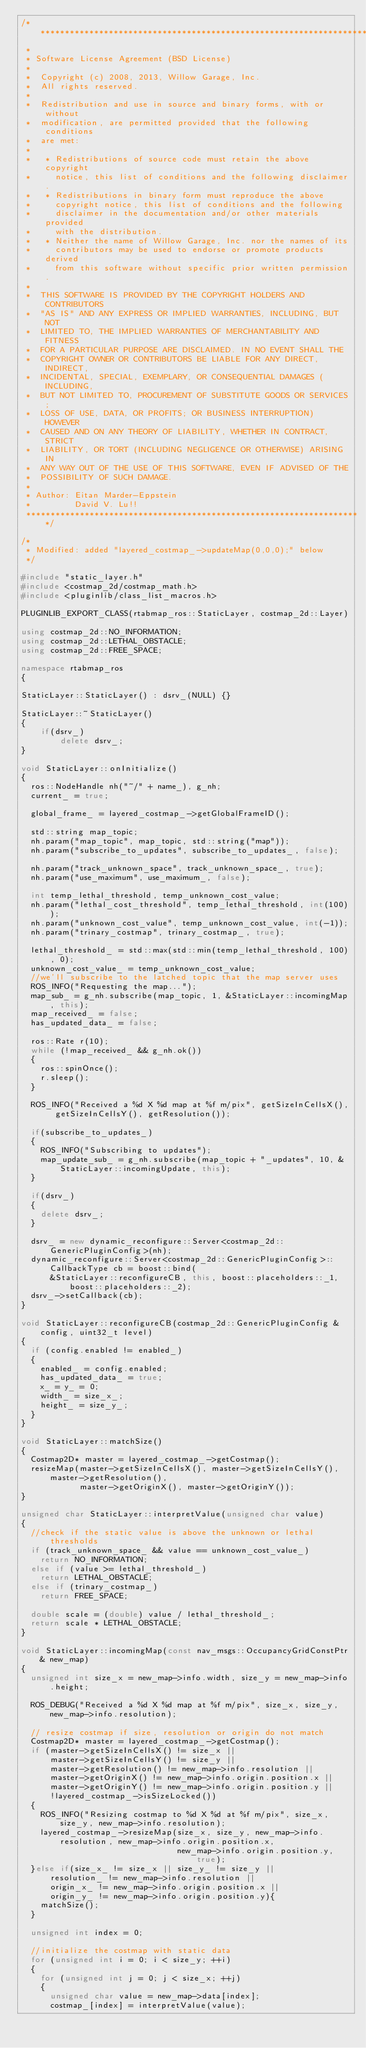<code> <loc_0><loc_0><loc_500><loc_500><_C++_>/*********************************************************************
 *
 * Software License Agreement (BSD License)
 *
 *  Copyright (c) 2008, 2013, Willow Garage, Inc.
 *  All rights reserved.
 *
 *  Redistribution and use in source and binary forms, with or without
 *  modification, are permitted provided that the following conditions
 *  are met:
 *
 *   * Redistributions of source code must retain the above copyright
 *     notice, this list of conditions and the following disclaimer.
 *   * Redistributions in binary form must reproduce the above
 *     copyright notice, this list of conditions and the following
 *     disclaimer in the documentation and/or other materials provided
 *     with the distribution.
 *   * Neither the name of Willow Garage, Inc. nor the names of its
 *     contributors may be used to endorse or promote products derived
 *     from this software without specific prior written permission.
 *
 *  THIS SOFTWARE IS PROVIDED BY THE COPYRIGHT HOLDERS AND CONTRIBUTORS
 *  "AS IS" AND ANY EXPRESS OR IMPLIED WARRANTIES, INCLUDING, BUT NOT
 *  LIMITED TO, THE IMPLIED WARRANTIES OF MERCHANTABILITY AND FITNESS
 *  FOR A PARTICULAR PURPOSE ARE DISCLAIMED. IN NO EVENT SHALL THE
 *  COPYRIGHT OWNER OR CONTRIBUTORS BE LIABLE FOR ANY DIRECT, INDIRECT,
 *  INCIDENTAL, SPECIAL, EXEMPLARY, OR CONSEQUENTIAL DAMAGES (INCLUDING,
 *  BUT NOT LIMITED TO, PROCUREMENT OF SUBSTITUTE GOODS OR SERVICES;
 *  LOSS OF USE, DATA, OR PROFITS; OR BUSINESS INTERRUPTION) HOWEVER
 *  CAUSED AND ON ANY THEORY OF LIABILITY, WHETHER IN CONTRACT, STRICT
 *  LIABILITY, OR TORT (INCLUDING NEGLIGENCE OR OTHERWISE) ARISING IN
 *  ANY WAY OUT OF THE USE OF THIS SOFTWARE, EVEN IF ADVISED OF THE
 *  POSSIBILITY OF SUCH DAMAGE.
 *
 * Author: Eitan Marder-Eppstein
 *         David V. Lu!!
 *********************************************************************/

/*
 * Modified: added "layered_costmap_->updateMap(0,0,0);" below
 */

#include "static_layer.h"
#include <costmap_2d/costmap_math.h>
#include <pluginlib/class_list_macros.h>

PLUGINLIB_EXPORT_CLASS(rtabmap_ros::StaticLayer, costmap_2d::Layer)

using costmap_2d::NO_INFORMATION;
using costmap_2d::LETHAL_OBSTACLE;
using costmap_2d::FREE_SPACE;

namespace rtabmap_ros
{

StaticLayer::StaticLayer() : dsrv_(NULL) {}

StaticLayer::~StaticLayer()
{
    if(dsrv_)
        delete dsrv_;
}

void StaticLayer::onInitialize()
{
  ros::NodeHandle nh("~/" + name_), g_nh;
  current_ = true;

  global_frame_ = layered_costmap_->getGlobalFrameID();

  std::string map_topic;
  nh.param("map_topic", map_topic, std::string("map"));
  nh.param("subscribe_to_updates", subscribe_to_updates_, false);
  
  nh.param("track_unknown_space", track_unknown_space_, true);
  nh.param("use_maximum", use_maximum_, false);

  int temp_lethal_threshold, temp_unknown_cost_value;
  nh.param("lethal_cost_threshold", temp_lethal_threshold, int(100));
  nh.param("unknown_cost_value", temp_unknown_cost_value, int(-1));
  nh.param("trinary_costmap", trinary_costmap_, true);

  lethal_threshold_ = std::max(std::min(temp_lethal_threshold, 100), 0);
  unknown_cost_value_ = temp_unknown_cost_value;
  //we'll subscribe to the latched topic that the map server uses
  ROS_INFO("Requesting the map...");
  map_sub_ = g_nh.subscribe(map_topic, 1, &StaticLayer::incomingMap, this);
  map_received_ = false;
  has_updated_data_ = false;

  ros::Rate r(10);
  while (!map_received_ && g_nh.ok())
  {
    ros::spinOnce();
    r.sleep();
  }

  ROS_INFO("Received a %d X %d map at %f m/pix", getSizeInCellsX(), getSizeInCellsY(), getResolution());
  
  if(subscribe_to_updates_)
  {
    ROS_INFO("Subscribing to updates");
    map_update_sub_ = g_nh.subscribe(map_topic + "_updates", 10, &StaticLayer::incomingUpdate, this);
  }

  if(dsrv_)
  {
    delete dsrv_;
  }

  dsrv_ = new dynamic_reconfigure::Server<costmap_2d::GenericPluginConfig>(nh);
  dynamic_reconfigure::Server<costmap_2d::GenericPluginConfig>::CallbackType cb = boost::bind(
      &StaticLayer::reconfigureCB, this, boost::placeholders::_1, boost::placeholders::_2);
  dsrv_->setCallback(cb);
}

void StaticLayer::reconfigureCB(costmap_2d::GenericPluginConfig &config, uint32_t level)
{
  if (config.enabled != enabled_)
  {
    enabled_ = config.enabled;
    has_updated_data_ = true;
    x_ = y_ = 0;
    width_ = size_x_;
    height_ = size_y_;
  }
}

void StaticLayer::matchSize()
{
  Costmap2D* master = layered_costmap_->getCostmap();
  resizeMap(master->getSizeInCellsX(), master->getSizeInCellsY(), master->getResolution(),
            master->getOriginX(), master->getOriginY());
}

unsigned char StaticLayer::interpretValue(unsigned char value)
{
  //check if the static value is above the unknown or lethal thresholds
  if (track_unknown_space_ && value == unknown_cost_value_)
    return NO_INFORMATION;
  else if (value >= lethal_threshold_)
    return LETHAL_OBSTACLE;
  else if (trinary_costmap_)
    return FREE_SPACE;

  double scale = (double) value / lethal_threshold_;
  return scale * LETHAL_OBSTACLE;
}

void StaticLayer::incomingMap(const nav_msgs::OccupancyGridConstPtr& new_map)
{
  unsigned int size_x = new_map->info.width, size_y = new_map->info.height;

  ROS_DEBUG("Received a %d X %d map at %f m/pix", size_x, size_y, new_map->info.resolution);

  // resize costmap if size, resolution or origin do not match
  Costmap2D* master = layered_costmap_->getCostmap();
  if (master->getSizeInCellsX() != size_x ||
      master->getSizeInCellsY() != size_y ||
      master->getResolution() != new_map->info.resolution ||
      master->getOriginX() != new_map->info.origin.position.x ||
      master->getOriginY() != new_map->info.origin.position.y ||
      !layered_costmap_->isSizeLocked())
  {
    ROS_INFO("Resizing costmap to %d X %d at %f m/pix", size_x, size_y, new_map->info.resolution);
    layered_costmap_->resizeMap(size_x, size_y, new_map->info.resolution, new_map->info.origin.position.x,
                                new_map->info.origin.position.y, true);
  }else if(size_x_ != size_x || size_y_ != size_y ||
      resolution_ != new_map->info.resolution ||
      origin_x_ != new_map->info.origin.position.x ||
      origin_y_ != new_map->info.origin.position.y){
    matchSize();
  }

  unsigned int index = 0;

  //initialize the costmap with static data
  for (unsigned int i = 0; i < size_y; ++i)
  {
    for (unsigned int j = 0; j < size_x; ++j)
    {
      unsigned char value = new_map->data[index];
      costmap_[index] = interpretValue(value);</code> 